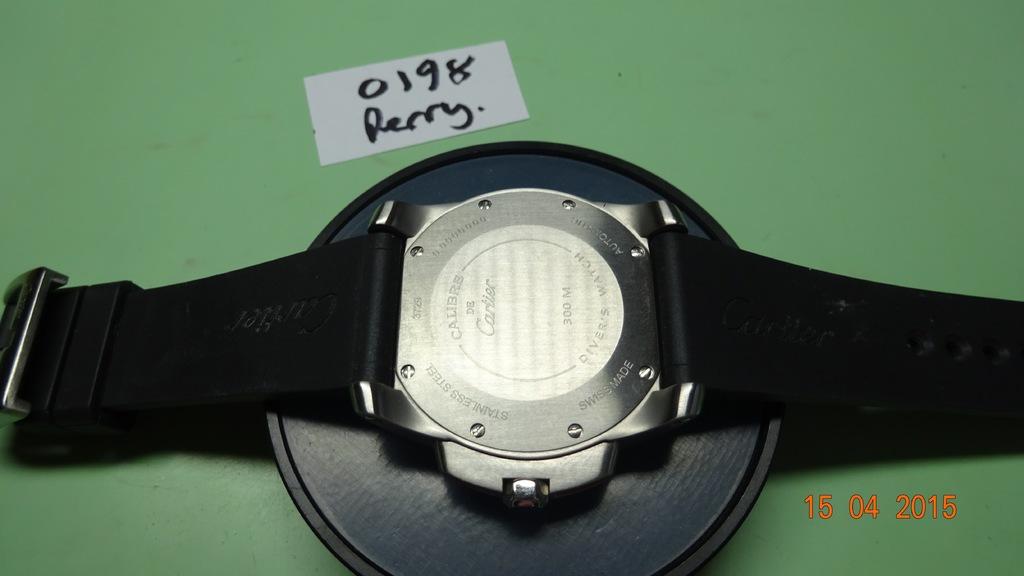What year was this photo taken?
Your response must be concise. 2015. 